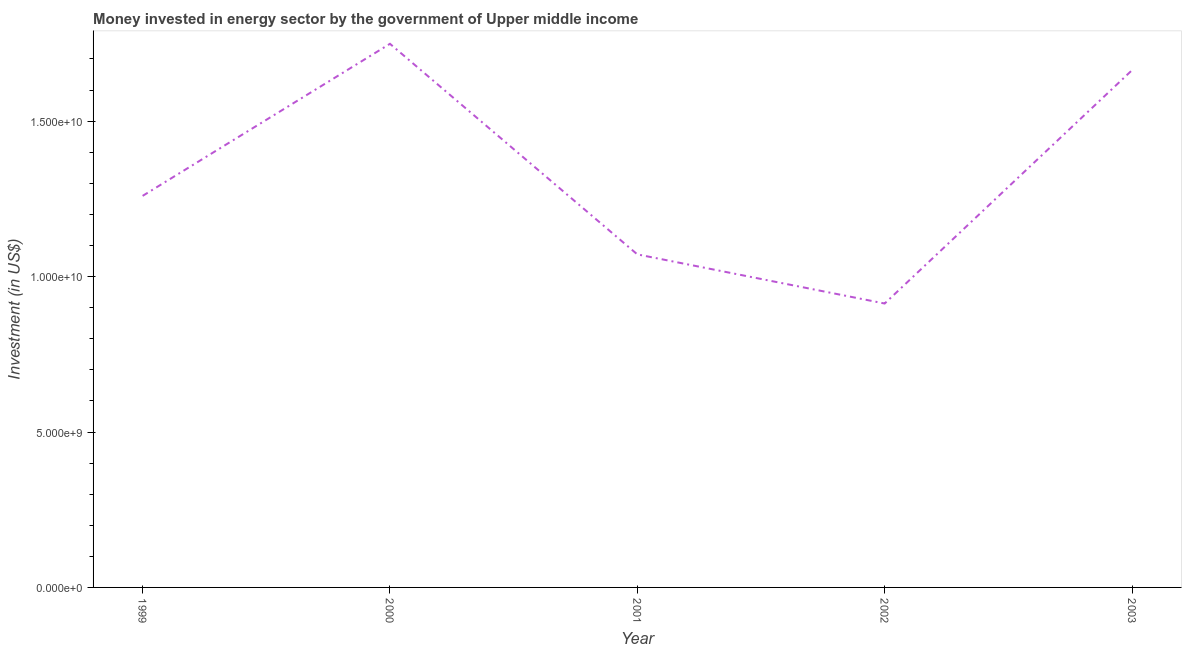What is the investment in energy in 2003?
Your answer should be very brief. 1.66e+1. Across all years, what is the maximum investment in energy?
Give a very brief answer. 1.75e+1. Across all years, what is the minimum investment in energy?
Keep it short and to the point. 9.13e+09. In which year was the investment in energy maximum?
Your response must be concise. 2000. In which year was the investment in energy minimum?
Provide a short and direct response. 2002. What is the sum of the investment in energy?
Ensure brevity in your answer.  6.66e+1. What is the difference between the investment in energy in 2001 and 2002?
Ensure brevity in your answer.  1.58e+09. What is the average investment in energy per year?
Your response must be concise. 1.33e+1. What is the median investment in energy?
Your response must be concise. 1.26e+1. In how many years, is the investment in energy greater than 4000000000 US$?
Provide a short and direct response. 5. Do a majority of the years between 1999 and 2002 (inclusive) have investment in energy greater than 1000000000 US$?
Keep it short and to the point. Yes. What is the ratio of the investment in energy in 2001 to that in 2002?
Offer a very short reply. 1.17. Is the investment in energy in 2000 less than that in 2002?
Provide a succinct answer. No. What is the difference between the highest and the second highest investment in energy?
Offer a very short reply. 8.49e+08. What is the difference between the highest and the lowest investment in energy?
Your answer should be very brief. 8.35e+09. In how many years, is the investment in energy greater than the average investment in energy taken over all years?
Provide a succinct answer. 2. Does the investment in energy monotonically increase over the years?
Your answer should be very brief. No. Are the values on the major ticks of Y-axis written in scientific E-notation?
Offer a terse response. Yes. Does the graph contain grids?
Keep it short and to the point. No. What is the title of the graph?
Offer a terse response. Money invested in energy sector by the government of Upper middle income. What is the label or title of the Y-axis?
Ensure brevity in your answer.  Investment (in US$). What is the Investment (in US$) of 1999?
Provide a short and direct response. 1.26e+1. What is the Investment (in US$) of 2000?
Keep it short and to the point. 1.75e+1. What is the Investment (in US$) in 2001?
Your response must be concise. 1.07e+1. What is the Investment (in US$) in 2002?
Your answer should be very brief. 9.13e+09. What is the Investment (in US$) in 2003?
Your answer should be very brief. 1.66e+1. What is the difference between the Investment (in US$) in 1999 and 2000?
Your answer should be very brief. -4.89e+09. What is the difference between the Investment (in US$) in 1999 and 2001?
Your answer should be very brief. 1.88e+09. What is the difference between the Investment (in US$) in 1999 and 2002?
Provide a short and direct response. 3.46e+09. What is the difference between the Investment (in US$) in 1999 and 2003?
Give a very brief answer. -4.04e+09. What is the difference between the Investment (in US$) in 2000 and 2001?
Provide a succinct answer. 6.77e+09. What is the difference between the Investment (in US$) in 2000 and 2002?
Offer a very short reply. 8.35e+09. What is the difference between the Investment (in US$) in 2000 and 2003?
Your answer should be very brief. 8.49e+08. What is the difference between the Investment (in US$) in 2001 and 2002?
Keep it short and to the point. 1.58e+09. What is the difference between the Investment (in US$) in 2001 and 2003?
Keep it short and to the point. -5.93e+09. What is the difference between the Investment (in US$) in 2002 and 2003?
Your answer should be very brief. -7.51e+09. What is the ratio of the Investment (in US$) in 1999 to that in 2000?
Your answer should be very brief. 0.72. What is the ratio of the Investment (in US$) in 1999 to that in 2001?
Make the answer very short. 1.18. What is the ratio of the Investment (in US$) in 1999 to that in 2002?
Your answer should be very brief. 1.38. What is the ratio of the Investment (in US$) in 1999 to that in 2003?
Keep it short and to the point. 0.76. What is the ratio of the Investment (in US$) in 2000 to that in 2001?
Make the answer very short. 1.63. What is the ratio of the Investment (in US$) in 2000 to that in 2002?
Your response must be concise. 1.92. What is the ratio of the Investment (in US$) in 2000 to that in 2003?
Make the answer very short. 1.05. What is the ratio of the Investment (in US$) in 2001 to that in 2002?
Keep it short and to the point. 1.17. What is the ratio of the Investment (in US$) in 2001 to that in 2003?
Keep it short and to the point. 0.64. What is the ratio of the Investment (in US$) in 2002 to that in 2003?
Keep it short and to the point. 0.55. 